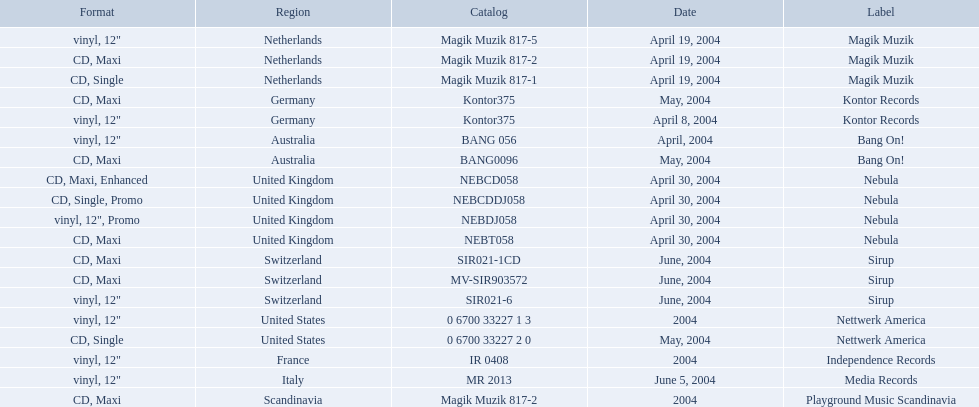What label was used by the netherlands in love comes again? Magik Muzik. What label was used in germany? Kontor Records. What label was used in france? Independence Records. 